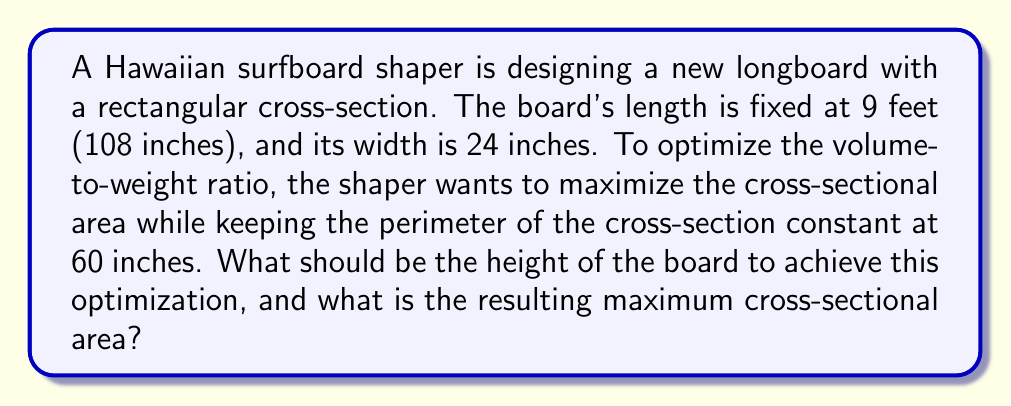Solve this math problem. Let's approach this step-by-step:

1) Let the height of the board be $h$ inches. Since the width is 24 inches, we can express the perimeter equation:

   $$2(24) + 2h = 60$$

2) Simplify:
   $$48 + 2h = 60$$
   $$2h = 12$$
   $$h = 6$$

3) Now, we need to verify if this indeed maximizes the area. The area function is:

   $$A(h) = 24h$$

4) To prove this is a maximum, we can use calculus. The derivative of the area with respect to h is:

   $$\frac{dA}{dh} = 24$$

5) This is always positive, meaning the area increases as h increases. However, we are constrained by the perimeter condition. Therefore, the maximum area occurs at the largest possible h value that satisfies the perimeter constraint, which we found to be 6 inches.

6) The maximum cross-sectional area is thus:

   $$A_{max} = 24 * 6 = 144$$ square inches

7) We can visualize this with an Asymptote diagram:

[asy]
unitsize(0.1 inch);
draw((0,0)--(24,0)--(24,6)--(0,6)--cycle);
label("24\"", (12,0), S);
label("6\"", (24,3), E);
[/asy]

This rectangular cross-section optimizes the volume-to-weight ratio by maximizing the cross-sectional area for the given perimeter constraint.
Answer: The optimal height of the board should be 6 inches, resulting in a maximum cross-sectional area of 144 square inches. 